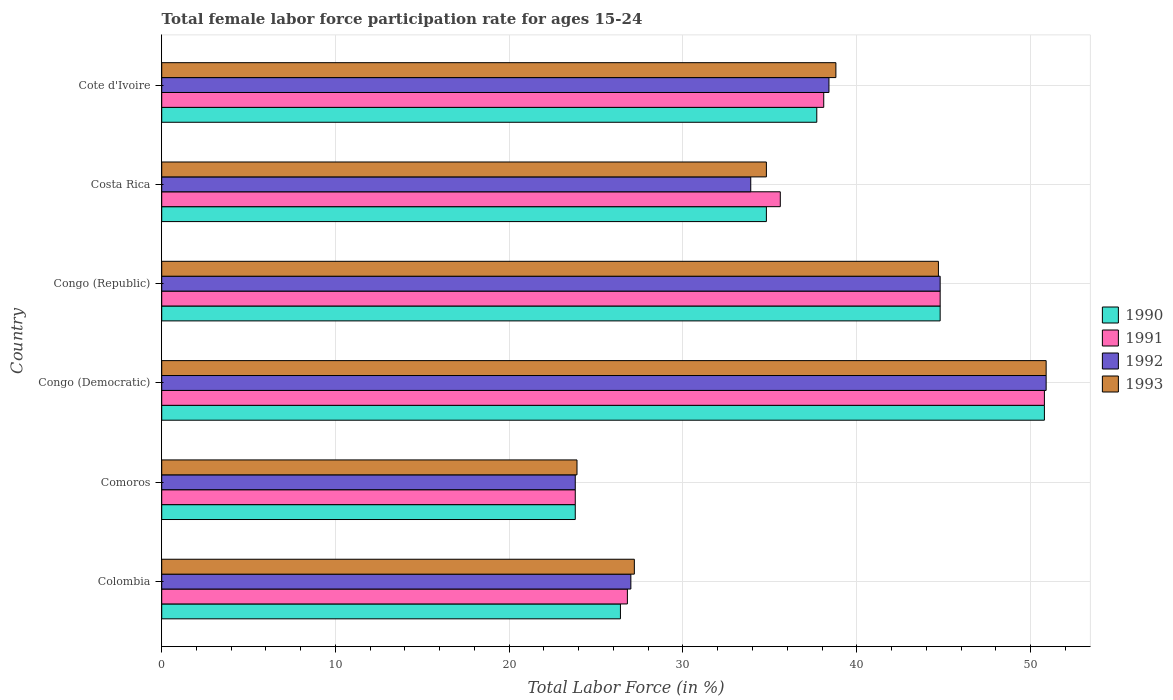How many different coloured bars are there?
Make the answer very short. 4. How many groups of bars are there?
Keep it short and to the point. 6. Are the number of bars per tick equal to the number of legend labels?
Your answer should be compact. Yes. What is the label of the 5th group of bars from the top?
Offer a terse response. Comoros. What is the female labor force participation rate in 1990 in Congo (Democratic)?
Offer a terse response. 50.8. Across all countries, what is the maximum female labor force participation rate in 1993?
Give a very brief answer. 50.9. Across all countries, what is the minimum female labor force participation rate in 1991?
Offer a terse response. 23.8. In which country was the female labor force participation rate in 1990 maximum?
Ensure brevity in your answer.  Congo (Democratic). In which country was the female labor force participation rate in 1991 minimum?
Ensure brevity in your answer.  Comoros. What is the total female labor force participation rate in 1993 in the graph?
Offer a very short reply. 220.3. What is the difference between the female labor force participation rate in 1991 in Colombia and that in Cote d'Ivoire?
Keep it short and to the point. -11.3. What is the difference between the female labor force participation rate in 1990 in Colombia and the female labor force participation rate in 1992 in Cote d'Ivoire?
Keep it short and to the point. -12. What is the average female labor force participation rate in 1993 per country?
Your answer should be very brief. 36.72. What is the difference between the female labor force participation rate in 1993 and female labor force participation rate in 1990 in Congo (Democratic)?
Offer a terse response. 0.1. What is the ratio of the female labor force participation rate in 1992 in Congo (Democratic) to that in Costa Rica?
Provide a short and direct response. 1.5. Is the female labor force participation rate in 1993 in Congo (Democratic) less than that in Cote d'Ivoire?
Ensure brevity in your answer.  No. Is the difference between the female labor force participation rate in 1993 in Comoros and Congo (Republic) greater than the difference between the female labor force participation rate in 1990 in Comoros and Congo (Republic)?
Make the answer very short. Yes. What is the difference between the highest and the second highest female labor force participation rate in 1990?
Provide a succinct answer. 6. What is the difference between the highest and the lowest female labor force participation rate in 1992?
Keep it short and to the point. 27.1. Is it the case that in every country, the sum of the female labor force participation rate in 1991 and female labor force participation rate in 1993 is greater than the sum of female labor force participation rate in 1990 and female labor force participation rate in 1992?
Keep it short and to the point. No. What does the 3rd bar from the top in Congo (Republic) represents?
Provide a short and direct response. 1991. Is it the case that in every country, the sum of the female labor force participation rate in 1992 and female labor force participation rate in 1993 is greater than the female labor force participation rate in 1990?
Keep it short and to the point. Yes. How many bars are there?
Offer a very short reply. 24. Are all the bars in the graph horizontal?
Offer a very short reply. Yes. How many countries are there in the graph?
Make the answer very short. 6. What is the difference between two consecutive major ticks on the X-axis?
Your answer should be compact. 10. Are the values on the major ticks of X-axis written in scientific E-notation?
Give a very brief answer. No. Does the graph contain any zero values?
Keep it short and to the point. No. Does the graph contain grids?
Provide a short and direct response. Yes. What is the title of the graph?
Offer a very short reply. Total female labor force participation rate for ages 15-24. What is the label or title of the Y-axis?
Give a very brief answer. Country. What is the Total Labor Force (in %) of 1990 in Colombia?
Give a very brief answer. 26.4. What is the Total Labor Force (in %) of 1991 in Colombia?
Make the answer very short. 26.8. What is the Total Labor Force (in %) in 1992 in Colombia?
Provide a succinct answer. 27. What is the Total Labor Force (in %) of 1993 in Colombia?
Ensure brevity in your answer.  27.2. What is the Total Labor Force (in %) in 1990 in Comoros?
Your response must be concise. 23.8. What is the Total Labor Force (in %) of 1991 in Comoros?
Provide a succinct answer. 23.8. What is the Total Labor Force (in %) in 1992 in Comoros?
Keep it short and to the point. 23.8. What is the Total Labor Force (in %) in 1993 in Comoros?
Offer a very short reply. 23.9. What is the Total Labor Force (in %) in 1990 in Congo (Democratic)?
Make the answer very short. 50.8. What is the Total Labor Force (in %) of 1991 in Congo (Democratic)?
Your answer should be compact. 50.8. What is the Total Labor Force (in %) in 1992 in Congo (Democratic)?
Provide a succinct answer. 50.9. What is the Total Labor Force (in %) in 1993 in Congo (Democratic)?
Your answer should be compact. 50.9. What is the Total Labor Force (in %) of 1990 in Congo (Republic)?
Keep it short and to the point. 44.8. What is the Total Labor Force (in %) in 1991 in Congo (Republic)?
Ensure brevity in your answer.  44.8. What is the Total Labor Force (in %) in 1992 in Congo (Republic)?
Your answer should be compact. 44.8. What is the Total Labor Force (in %) in 1993 in Congo (Republic)?
Keep it short and to the point. 44.7. What is the Total Labor Force (in %) in 1990 in Costa Rica?
Your answer should be very brief. 34.8. What is the Total Labor Force (in %) in 1991 in Costa Rica?
Offer a terse response. 35.6. What is the Total Labor Force (in %) of 1992 in Costa Rica?
Keep it short and to the point. 33.9. What is the Total Labor Force (in %) in 1993 in Costa Rica?
Your response must be concise. 34.8. What is the Total Labor Force (in %) in 1990 in Cote d'Ivoire?
Offer a very short reply. 37.7. What is the Total Labor Force (in %) in 1991 in Cote d'Ivoire?
Provide a succinct answer. 38.1. What is the Total Labor Force (in %) in 1992 in Cote d'Ivoire?
Ensure brevity in your answer.  38.4. What is the Total Labor Force (in %) in 1993 in Cote d'Ivoire?
Offer a very short reply. 38.8. Across all countries, what is the maximum Total Labor Force (in %) of 1990?
Your response must be concise. 50.8. Across all countries, what is the maximum Total Labor Force (in %) of 1991?
Provide a short and direct response. 50.8. Across all countries, what is the maximum Total Labor Force (in %) of 1992?
Your answer should be very brief. 50.9. Across all countries, what is the maximum Total Labor Force (in %) of 1993?
Your response must be concise. 50.9. Across all countries, what is the minimum Total Labor Force (in %) in 1990?
Keep it short and to the point. 23.8. Across all countries, what is the minimum Total Labor Force (in %) in 1991?
Your answer should be very brief. 23.8. Across all countries, what is the minimum Total Labor Force (in %) of 1992?
Give a very brief answer. 23.8. Across all countries, what is the minimum Total Labor Force (in %) in 1993?
Offer a terse response. 23.9. What is the total Total Labor Force (in %) of 1990 in the graph?
Offer a terse response. 218.3. What is the total Total Labor Force (in %) in 1991 in the graph?
Ensure brevity in your answer.  219.9. What is the total Total Labor Force (in %) in 1992 in the graph?
Your response must be concise. 218.8. What is the total Total Labor Force (in %) of 1993 in the graph?
Keep it short and to the point. 220.3. What is the difference between the Total Labor Force (in %) of 1990 in Colombia and that in Comoros?
Offer a very short reply. 2.6. What is the difference between the Total Labor Force (in %) in 1993 in Colombia and that in Comoros?
Make the answer very short. 3.3. What is the difference between the Total Labor Force (in %) of 1990 in Colombia and that in Congo (Democratic)?
Your answer should be compact. -24.4. What is the difference between the Total Labor Force (in %) of 1992 in Colombia and that in Congo (Democratic)?
Offer a very short reply. -23.9. What is the difference between the Total Labor Force (in %) of 1993 in Colombia and that in Congo (Democratic)?
Provide a short and direct response. -23.7. What is the difference between the Total Labor Force (in %) in 1990 in Colombia and that in Congo (Republic)?
Offer a terse response. -18.4. What is the difference between the Total Labor Force (in %) in 1991 in Colombia and that in Congo (Republic)?
Provide a short and direct response. -18. What is the difference between the Total Labor Force (in %) of 1992 in Colombia and that in Congo (Republic)?
Give a very brief answer. -17.8. What is the difference between the Total Labor Force (in %) of 1993 in Colombia and that in Congo (Republic)?
Give a very brief answer. -17.5. What is the difference between the Total Labor Force (in %) in 1990 in Colombia and that in Costa Rica?
Your answer should be very brief. -8.4. What is the difference between the Total Labor Force (in %) in 1991 in Colombia and that in Costa Rica?
Your answer should be very brief. -8.8. What is the difference between the Total Labor Force (in %) of 1992 in Colombia and that in Costa Rica?
Your answer should be compact. -6.9. What is the difference between the Total Labor Force (in %) in 1993 in Colombia and that in Costa Rica?
Provide a succinct answer. -7.6. What is the difference between the Total Labor Force (in %) of 1991 in Colombia and that in Cote d'Ivoire?
Provide a short and direct response. -11.3. What is the difference between the Total Labor Force (in %) in 1992 in Comoros and that in Congo (Democratic)?
Make the answer very short. -27.1. What is the difference between the Total Labor Force (in %) in 1990 in Comoros and that in Congo (Republic)?
Keep it short and to the point. -21. What is the difference between the Total Labor Force (in %) in 1993 in Comoros and that in Congo (Republic)?
Make the answer very short. -20.8. What is the difference between the Total Labor Force (in %) in 1991 in Comoros and that in Costa Rica?
Ensure brevity in your answer.  -11.8. What is the difference between the Total Labor Force (in %) in 1990 in Comoros and that in Cote d'Ivoire?
Offer a terse response. -13.9. What is the difference between the Total Labor Force (in %) in 1991 in Comoros and that in Cote d'Ivoire?
Keep it short and to the point. -14.3. What is the difference between the Total Labor Force (in %) in 1992 in Comoros and that in Cote d'Ivoire?
Offer a terse response. -14.6. What is the difference between the Total Labor Force (in %) of 1993 in Comoros and that in Cote d'Ivoire?
Your response must be concise. -14.9. What is the difference between the Total Labor Force (in %) in 1990 in Congo (Democratic) and that in Congo (Republic)?
Offer a very short reply. 6. What is the difference between the Total Labor Force (in %) in 1992 in Congo (Democratic) and that in Congo (Republic)?
Your response must be concise. 6.1. What is the difference between the Total Labor Force (in %) in 1992 in Congo (Democratic) and that in Costa Rica?
Provide a succinct answer. 17. What is the difference between the Total Labor Force (in %) in 1993 in Congo (Democratic) and that in Costa Rica?
Make the answer very short. 16.1. What is the difference between the Total Labor Force (in %) in 1990 in Congo (Democratic) and that in Cote d'Ivoire?
Make the answer very short. 13.1. What is the difference between the Total Labor Force (in %) in 1991 in Congo (Democratic) and that in Cote d'Ivoire?
Provide a succinct answer. 12.7. What is the difference between the Total Labor Force (in %) in 1991 in Congo (Republic) and that in Costa Rica?
Offer a terse response. 9.2. What is the difference between the Total Labor Force (in %) of 1991 in Congo (Republic) and that in Cote d'Ivoire?
Make the answer very short. 6.7. What is the difference between the Total Labor Force (in %) of 1992 in Congo (Republic) and that in Cote d'Ivoire?
Your answer should be compact. 6.4. What is the difference between the Total Labor Force (in %) in 1993 in Congo (Republic) and that in Cote d'Ivoire?
Make the answer very short. 5.9. What is the difference between the Total Labor Force (in %) of 1990 in Costa Rica and that in Cote d'Ivoire?
Your answer should be very brief. -2.9. What is the difference between the Total Labor Force (in %) in 1992 in Costa Rica and that in Cote d'Ivoire?
Offer a very short reply. -4.5. What is the difference between the Total Labor Force (in %) of 1990 in Colombia and the Total Labor Force (in %) of 1991 in Comoros?
Your response must be concise. 2.6. What is the difference between the Total Labor Force (in %) of 1991 in Colombia and the Total Labor Force (in %) of 1993 in Comoros?
Ensure brevity in your answer.  2.9. What is the difference between the Total Labor Force (in %) in 1990 in Colombia and the Total Labor Force (in %) in 1991 in Congo (Democratic)?
Make the answer very short. -24.4. What is the difference between the Total Labor Force (in %) of 1990 in Colombia and the Total Labor Force (in %) of 1992 in Congo (Democratic)?
Your answer should be compact. -24.5. What is the difference between the Total Labor Force (in %) of 1990 in Colombia and the Total Labor Force (in %) of 1993 in Congo (Democratic)?
Ensure brevity in your answer.  -24.5. What is the difference between the Total Labor Force (in %) of 1991 in Colombia and the Total Labor Force (in %) of 1992 in Congo (Democratic)?
Provide a short and direct response. -24.1. What is the difference between the Total Labor Force (in %) in 1991 in Colombia and the Total Labor Force (in %) in 1993 in Congo (Democratic)?
Offer a terse response. -24.1. What is the difference between the Total Labor Force (in %) in 1992 in Colombia and the Total Labor Force (in %) in 1993 in Congo (Democratic)?
Give a very brief answer. -23.9. What is the difference between the Total Labor Force (in %) in 1990 in Colombia and the Total Labor Force (in %) in 1991 in Congo (Republic)?
Keep it short and to the point. -18.4. What is the difference between the Total Labor Force (in %) of 1990 in Colombia and the Total Labor Force (in %) of 1992 in Congo (Republic)?
Provide a short and direct response. -18.4. What is the difference between the Total Labor Force (in %) in 1990 in Colombia and the Total Labor Force (in %) in 1993 in Congo (Republic)?
Your answer should be compact. -18.3. What is the difference between the Total Labor Force (in %) of 1991 in Colombia and the Total Labor Force (in %) of 1993 in Congo (Republic)?
Your answer should be very brief. -17.9. What is the difference between the Total Labor Force (in %) in 1992 in Colombia and the Total Labor Force (in %) in 1993 in Congo (Republic)?
Ensure brevity in your answer.  -17.7. What is the difference between the Total Labor Force (in %) in 1990 in Colombia and the Total Labor Force (in %) in 1991 in Costa Rica?
Keep it short and to the point. -9.2. What is the difference between the Total Labor Force (in %) in 1991 in Colombia and the Total Labor Force (in %) in 1992 in Costa Rica?
Your answer should be very brief. -7.1. What is the difference between the Total Labor Force (in %) of 1991 in Colombia and the Total Labor Force (in %) of 1992 in Cote d'Ivoire?
Your answer should be very brief. -11.6. What is the difference between the Total Labor Force (in %) of 1991 in Colombia and the Total Labor Force (in %) of 1993 in Cote d'Ivoire?
Keep it short and to the point. -12. What is the difference between the Total Labor Force (in %) in 1992 in Colombia and the Total Labor Force (in %) in 1993 in Cote d'Ivoire?
Your response must be concise. -11.8. What is the difference between the Total Labor Force (in %) in 1990 in Comoros and the Total Labor Force (in %) in 1991 in Congo (Democratic)?
Give a very brief answer. -27. What is the difference between the Total Labor Force (in %) of 1990 in Comoros and the Total Labor Force (in %) of 1992 in Congo (Democratic)?
Ensure brevity in your answer.  -27.1. What is the difference between the Total Labor Force (in %) in 1990 in Comoros and the Total Labor Force (in %) in 1993 in Congo (Democratic)?
Offer a terse response. -27.1. What is the difference between the Total Labor Force (in %) in 1991 in Comoros and the Total Labor Force (in %) in 1992 in Congo (Democratic)?
Your response must be concise. -27.1. What is the difference between the Total Labor Force (in %) of 1991 in Comoros and the Total Labor Force (in %) of 1993 in Congo (Democratic)?
Provide a succinct answer. -27.1. What is the difference between the Total Labor Force (in %) of 1992 in Comoros and the Total Labor Force (in %) of 1993 in Congo (Democratic)?
Provide a short and direct response. -27.1. What is the difference between the Total Labor Force (in %) in 1990 in Comoros and the Total Labor Force (in %) in 1992 in Congo (Republic)?
Your answer should be very brief. -21. What is the difference between the Total Labor Force (in %) of 1990 in Comoros and the Total Labor Force (in %) of 1993 in Congo (Republic)?
Your answer should be compact. -20.9. What is the difference between the Total Labor Force (in %) in 1991 in Comoros and the Total Labor Force (in %) in 1993 in Congo (Republic)?
Make the answer very short. -20.9. What is the difference between the Total Labor Force (in %) of 1992 in Comoros and the Total Labor Force (in %) of 1993 in Congo (Republic)?
Offer a very short reply. -20.9. What is the difference between the Total Labor Force (in %) in 1990 in Comoros and the Total Labor Force (in %) in 1992 in Costa Rica?
Make the answer very short. -10.1. What is the difference between the Total Labor Force (in %) of 1990 in Comoros and the Total Labor Force (in %) of 1993 in Costa Rica?
Keep it short and to the point. -11. What is the difference between the Total Labor Force (in %) in 1991 in Comoros and the Total Labor Force (in %) in 1992 in Costa Rica?
Offer a terse response. -10.1. What is the difference between the Total Labor Force (in %) in 1992 in Comoros and the Total Labor Force (in %) in 1993 in Costa Rica?
Make the answer very short. -11. What is the difference between the Total Labor Force (in %) in 1990 in Comoros and the Total Labor Force (in %) in 1991 in Cote d'Ivoire?
Ensure brevity in your answer.  -14.3. What is the difference between the Total Labor Force (in %) in 1990 in Comoros and the Total Labor Force (in %) in 1992 in Cote d'Ivoire?
Your answer should be very brief. -14.6. What is the difference between the Total Labor Force (in %) in 1991 in Comoros and the Total Labor Force (in %) in 1992 in Cote d'Ivoire?
Your answer should be very brief. -14.6. What is the difference between the Total Labor Force (in %) in 1990 in Congo (Democratic) and the Total Labor Force (in %) in 1991 in Congo (Republic)?
Ensure brevity in your answer.  6. What is the difference between the Total Labor Force (in %) in 1990 in Congo (Democratic) and the Total Labor Force (in %) in 1993 in Congo (Republic)?
Your response must be concise. 6.1. What is the difference between the Total Labor Force (in %) of 1991 in Congo (Democratic) and the Total Labor Force (in %) of 1993 in Congo (Republic)?
Offer a terse response. 6.1. What is the difference between the Total Labor Force (in %) in 1990 in Congo (Democratic) and the Total Labor Force (in %) in 1991 in Costa Rica?
Ensure brevity in your answer.  15.2. What is the difference between the Total Labor Force (in %) of 1990 in Congo (Democratic) and the Total Labor Force (in %) of 1992 in Costa Rica?
Offer a very short reply. 16.9. What is the difference between the Total Labor Force (in %) in 1991 in Congo (Democratic) and the Total Labor Force (in %) in 1992 in Costa Rica?
Your answer should be very brief. 16.9. What is the difference between the Total Labor Force (in %) of 1991 in Congo (Democratic) and the Total Labor Force (in %) of 1993 in Costa Rica?
Your answer should be very brief. 16. What is the difference between the Total Labor Force (in %) in 1992 in Congo (Democratic) and the Total Labor Force (in %) in 1993 in Costa Rica?
Your answer should be compact. 16.1. What is the difference between the Total Labor Force (in %) of 1991 in Congo (Democratic) and the Total Labor Force (in %) of 1993 in Cote d'Ivoire?
Give a very brief answer. 12. What is the difference between the Total Labor Force (in %) in 1990 in Congo (Republic) and the Total Labor Force (in %) in 1992 in Costa Rica?
Your answer should be very brief. 10.9. What is the difference between the Total Labor Force (in %) of 1991 in Congo (Republic) and the Total Labor Force (in %) of 1992 in Costa Rica?
Your answer should be very brief. 10.9. What is the difference between the Total Labor Force (in %) in 1992 in Congo (Republic) and the Total Labor Force (in %) in 1993 in Costa Rica?
Your answer should be compact. 10. What is the difference between the Total Labor Force (in %) of 1990 in Congo (Republic) and the Total Labor Force (in %) of 1992 in Cote d'Ivoire?
Your answer should be very brief. 6.4. What is the difference between the Total Labor Force (in %) of 1991 in Congo (Republic) and the Total Labor Force (in %) of 1992 in Cote d'Ivoire?
Provide a short and direct response. 6.4. What is the difference between the Total Labor Force (in %) in 1991 in Congo (Republic) and the Total Labor Force (in %) in 1993 in Cote d'Ivoire?
Your response must be concise. 6. What is the difference between the Total Labor Force (in %) of 1991 in Costa Rica and the Total Labor Force (in %) of 1992 in Cote d'Ivoire?
Offer a very short reply. -2.8. What is the difference between the Total Labor Force (in %) in 1991 in Costa Rica and the Total Labor Force (in %) in 1993 in Cote d'Ivoire?
Your answer should be very brief. -3.2. What is the difference between the Total Labor Force (in %) of 1992 in Costa Rica and the Total Labor Force (in %) of 1993 in Cote d'Ivoire?
Give a very brief answer. -4.9. What is the average Total Labor Force (in %) of 1990 per country?
Keep it short and to the point. 36.38. What is the average Total Labor Force (in %) of 1991 per country?
Offer a very short reply. 36.65. What is the average Total Labor Force (in %) of 1992 per country?
Offer a very short reply. 36.47. What is the average Total Labor Force (in %) in 1993 per country?
Make the answer very short. 36.72. What is the difference between the Total Labor Force (in %) in 1990 and Total Labor Force (in %) in 1991 in Colombia?
Offer a very short reply. -0.4. What is the difference between the Total Labor Force (in %) of 1990 and Total Labor Force (in %) of 1992 in Colombia?
Provide a short and direct response. -0.6. What is the difference between the Total Labor Force (in %) of 1990 and Total Labor Force (in %) of 1993 in Colombia?
Give a very brief answer. -0.8. What is the difference between the Total Labor Force (in %) of 1991 and Total Labor Force (in %) of 1992 in Colombia?
Provide a succinct answer. -0.2. What is the difference between the Total Labor Force (in %) of 1991 and Total Labor Force (in %) of 1993 in Colombia?
Ensure brevity in your answer.  -0.4. What is the difference between the Total Labor Force (in %) in 1992 and Total Labor Force (in %) in 1993 in Colombia?
Offer a terse response. -0.2. What is the difference between the Total Labor Force (in %) in 1990 and Total Labor Force (in %) in 1992 in Comoros?
Keep it short and to the point. 0. What is the difference between the Total Labor Force (in %) of 1990 and Total Labor Force (in %) of 1991 in Congo (Democratic)?
Your answer should be compact. 0. What is the difference between the Total Labor Force (in %) in 1990 and Total Labor Force (in %) in 1993 in Congo (Democratic)?
Your answer should be very brief. -0.1. What is the difference between the Total Labor Force (in %) of 1990 and Total Labor Force (in %) of 1992 in Congo (Republic)?
Provide a succinct answer. 0. What is the difference between the Total Labor Force (in %) of 1991 and Total Labor Force (in %) of 1992 in Congo (Republic)?
Make the answer very short. 0. What is the difference between the Total Labor Force (in %) in 1991 and Total Labor Force (in %) in 1993 in Congo (Republic)?
Provide a short and direct response. 0.1. What is the difference between the Total Labor Force (in %) in 1992 and Total Labor Force (in %) in 1993 in Congo (Republic)?
Your answer should be very brief. 0.1. What is the difference between the Total Labor Force (in %) in 1990 and Total Labor Force (in %) in 1991 in Costa Rica?
Provide a succinct answer. -0.8. What is the difference between the Total Labor Force (in %) in 1990 and Total Labor Force (in %) in 1992 in Costa Rica?
Make the answer very short. 0.9. What is the difference between the Total Labor Force (in %) in 1990 and Total Labor Force (in %) in 1993 in Costa Rica?
Ensure brevity in your answer.  0. What is the difference between the Total Labor Force (in %) of 1991 and Total Labor Force (in %) of 1992 in Costa Rica?
Provide a short and direct response. 1.7. What is the difference between the Total Labor Force (in %) in 1990 and Total Labor Force (in %) in 1992 in Cote d'Ivoire?
Provide a succinct answer. -0.7. What is the difference between the Total Labor Force (in %) of 1992 and Total Labor Force (in %) of 1993 in Cote d'Ivoire?
Your answer should be compact. -0.4. What is the ratio of the Total Labor Force (in %) of 1990 in Colombia to that in Comoros?
Your response must be concise. 1.11. What is the ratio of the Total Labor Force (in %) in 1991 in Colombia to that in Comoros?
Make the answer very short. 1.13. What is the ratio of the Total Labor Force (in %) in 1992 in Colombia to that in Comoros?
Offer a terse response. 1.13. What is the ratio of the Total Labor Force (in %) of 1993 in Colombia to that in Comoros?
Offer a very short reply. 1.14. What is the ratio of the Total Labor Force (in %) of 1990 in Colombia to that in Congo (Democratic)?
Ensure brevity in your answer.  0.52. What is the ratio of the Total Labor Force (in %) of 1991 in Colombia to that in Congo (Democratic)?
Your answer should be very brief. 0.53. What is the ratio of the Total Labor Force (in %) in 1992 in Colombia to that in Congo (Democratic)?
Offer a terse response. 0.53. What is the ratio of the Total Labor Force (in %) of 1993 in Colombia to that in Congo (Democratic)?
Your answer should be very brief. 0.53. What is the ratio of the Total Labor Force (in %) in 1990 in Colombia to that in Congo (Republic)?
Make the answer very short. 0.59. What is the ratio of the Total Labor Force (in %) in 1991 in Colombia to that in Congo (Republic)?
Offer a very short reply. 0.6. What is the ratio of the Total Labor Force (in %) of 1992 in Colombia to that in Congo (Republic)?
Give a very brief answer. 0.6. What is the ratio of the Total Labor Force (in %) of 1993 in Colombia to that in Congo (Republic)?
Provide a short and direct response. 0.61. What is the ratio of the Total Labor Force (in %) of 1990 in Colombia to that in Costa Rica?
Offer a very short reply. 0.76. What is the ratio of the Total Labor Force (in %) in 1991 in Colombia to that in Costa Rica?
Offer a terse response. 0.75. What is the ratio of the Total Labor Force (in %) of 1992 in Colombia to that in Costa Rica?
Offer a terse response. 0.8. What is the ratio of the Total Labor Force (in %) in 1993 in Colombia to that in Costa Rica?
Provide a short and direct response. 0.78. What is the ratio of the Total Labor Force (in %) of 1990 in Colombia to that in Cote d'Ivoire?
Provide a short and direct response. 0.7. What is the ratio of the Total Labor Force (in %) in 1991 in Colombia to that in Cote d'Ivoire?
Your response must be concise. 0.7. What is the ratio of the Total Labor Force (in %) in 1992 in Colombia to that in Cote d'Ivoire?
Your answer should be compact. 0.7. What is the ratio of the Total Labor Force (in %) in 1993 in Colombia to that in Cote d'Ivoire?
Your answer should be very brief. 0.7. What is the ratio of the Total Labor Force (in %) in 1990 in Comoros to that in Congo (Democratic)?
Ensure brevity in your answer.  0.47. What is the ratio of the Total Labor Force (in %) of 1991 in Comoros to that in Congo (Democratic)?
Make the answer very short. 0.47. What is the ratio of the Total Labor Force (in %) of 1992 in Comoros to that in Congo (Democratic)?
Offer a terse response. 0.47. What is the ratio of the Total Labor Force (in %) of 1993 in Comoros to that in Congo (Democratic)?
Keep it short and to the point. 0.47. What is the ratio of the Total Labor Force (in %) of 1990 in Comoros to that in Congo (Republic)?
Keep it short and to the point. 0.53. What is the ratio of the Total Labor Force (in %) of 1991 in Comoros to that in Congo (Republic)?
Provide a succinct answer. 0.53. What is the ratio of the Total Labor Force (in %) in 1992 in Comoros to that in Congo (Republic)?
Offer a very short reply. 0.53. What is the ratio of the Total Labor Force (in %) of 1993 in Comoros to that in Congo (Republic)?
Your response must be concise. 0.53. What is the ratio of the Total Labor Force (in %) in 1990 in Comoros to that in Costa Rica?
Your answer should be very brief. 0.68. What is the ratio of the Total Labor Force (in %) in 1991 in Comoros to that in Costa Rica?
Provide a short and direct response. 0.67. What is the ratio of the Total Labor Force (in %) of 1992 in Comoros to that in Costa Rica?
Your response must be concise. 0.7. What is the ratio of the Total Labor Force (in %) of 1993 in Comoros to that in Costa Rica?
Make the answer very short. 0.69. What is the ratio of the Total Labor Force (in %) in 1990 in Comoros to that in Cote d'Ivoire?
Provide a succinct answer. 0.63. What is the ratio of the Total Labor Force (in %) in 1991 in Comoros to that in Cote d'Ivoire?
Keep it short and to the point. 0.62. What is the ratio of the Total Labor Force (in %) of 1992 in Comoros to that in Cote d'Ivoire?
Your answer should be very brief. 0.62. What is the ratio of the Total Labor Force (in %) in 1993 in Comoros to that in Cote d'Ivoire?
Offer a very short reply. 0.62. What is the ratio of the Total Labor Force (in %) in 1990 in Congo (Democratic) to that in Congo (Republic)?
Your answer should be very brief. 1.13. What is the ratio of the Total Labor Force (in %) in 1991 in Congo (Democratic) to that in Congo (Republic)?
Your response must be concise. 1.13. What is the ratio of the Total Labor Force (in %) in 1992 in Congo (Democratic) to that in Congo (Republic)?
Make the answer very short. 1.14. What is the ratio of the Total Labor Force (in %) of 1993 in Congo (Democratic) to that in Congo (Republic)?
Provide a short and direct response. 1.14. What is the ratio of the Total Labor Force (in %) of 1990 in Congo (Democratic) to that in Costa Rica?
Your answer should be compact. 1.46. What is the ratio of the Total Labor Force (in %) in 1991 in Congo (Democratic) to that in Costa Rica?
Give a very brief answer. 1.43. What is the ratio of the Total Labor Force (in %) in 1992 in Congo (Democratic) to that in Costa Rica?
Ensure brevity in your answer.  1.5. What is the ratio of the Total Labor Force (in %) of 1993 in Congo (Democratic) to that in Costa Rica?
Your answer should be compact. 1.46. What is the ratio of the Total Labor Force (in %) of 1990 in Congo (Democratic) to that in Cote d'Ivoire?
Your answer should be very brief. 1.35. What is the ratio of the Total Labor Force (in %) in 1991 in Congo (Democratic) to that in Cote d'Ivoire?
Your answer should be compact. 1.33. What is the ratio of the Total Labor Force (in %) in 1992 in Congo (Democratic) to that in Cote d'Ivoire?
Your response must be concise. 1.33. What is the ratio of the Total Labor Force (in %) of 1993 in Congo (Democratic) to that in Cote d'Ivoire?
Keep it short and to the point. 1.31. What is the ratio of the Total Labor Force (in %) of 1990 in Congo (Republic) to that in Costa Rica?
Make the answer very short. 1.29. What is the ratio of the Total Labor Force (in %) in 1991 in Congo (Republic) to that in Costa Rica?
Make the answer very short. 1.26. What is the ratio of the Total Labor Force (in %) of 1992 in Congo (Republic) to that in Costa Rica?
Make the answer very short. 1.32. What is the ratio of the Total Labor Force (in %) in 1993 in Congo (Republic) to that in Costa Rica?
Ensure brevity in your answer.  1.28. What is the ratio of the Total Labor Force (in %) of 1990 in Congo (Republic) to that in Cote d'Ivoire?
Make the answer very short. 1.19. What is the ratio of the Total Labor Force (in %) of 1991 in Congo (Republic) to that in Cote d'Ivoire?
Offer a very short reply. 1.18. What is the ratio of the Total Labor Force (in %) of 1992 in Congo (Republic) to that in Cote d'Ivoire?
Offer a very short reply. 1.17. What is the ratio of the Total Labor Force (in %) of 1993 in Congo (Republic) to that in Cote d'Ivoire?
Keep it short and to the point. 1.15. What is the ratio of the Total Labor Force (in %) of 1991 in Costa Rica to that in Cote d'Ivoire?
Provide a short and direct response. 0.93. What is the ratio of the Total Labor Force (in %) in 1992 in Costa Rica to that in Cote d'Ivoire?
Keep it short and to the point. 0.88. What is the ratio of the Total Labor Force (in %) of 1993 in Costa Rica to that in Cote d'Ivoire?
Your answer should be compact. 0.9. What is the difference between the highest and the second highest Total Labor Force (in %) in 1990?
Your answer should be very brief. 6. What is the difference between the highest and the lowest Total Labor Force (in %) in 1990?
Ensure brevity in your answer.  27. What is the difference between the highest and the lowest Total Labor Force (in %) in 1991?
Your answer should be very brief. 27. What is the difference between the highest and the lowest Total Labor Force (in %) in 1992?
Give a very brief answer. 27.1. 